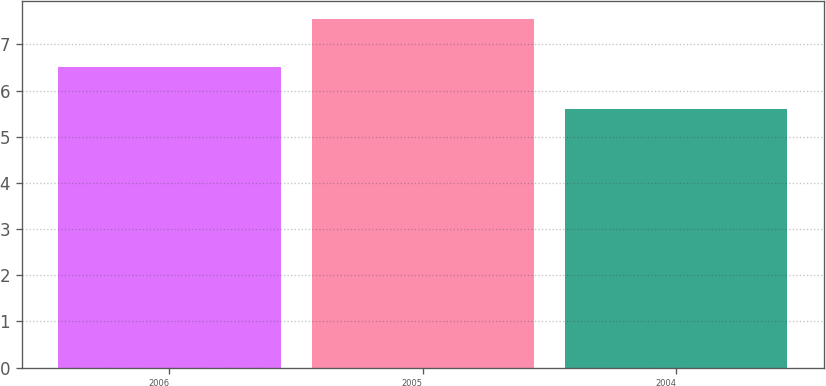Convert chart. <chart><loc_0><loc_0><loc_500><loc_500><bar_chart><fcel>2006<fcel>2005<fcel>2004<nl><fcel>6.52<fcel>7.56<fcel>5.61<nl></chart> 